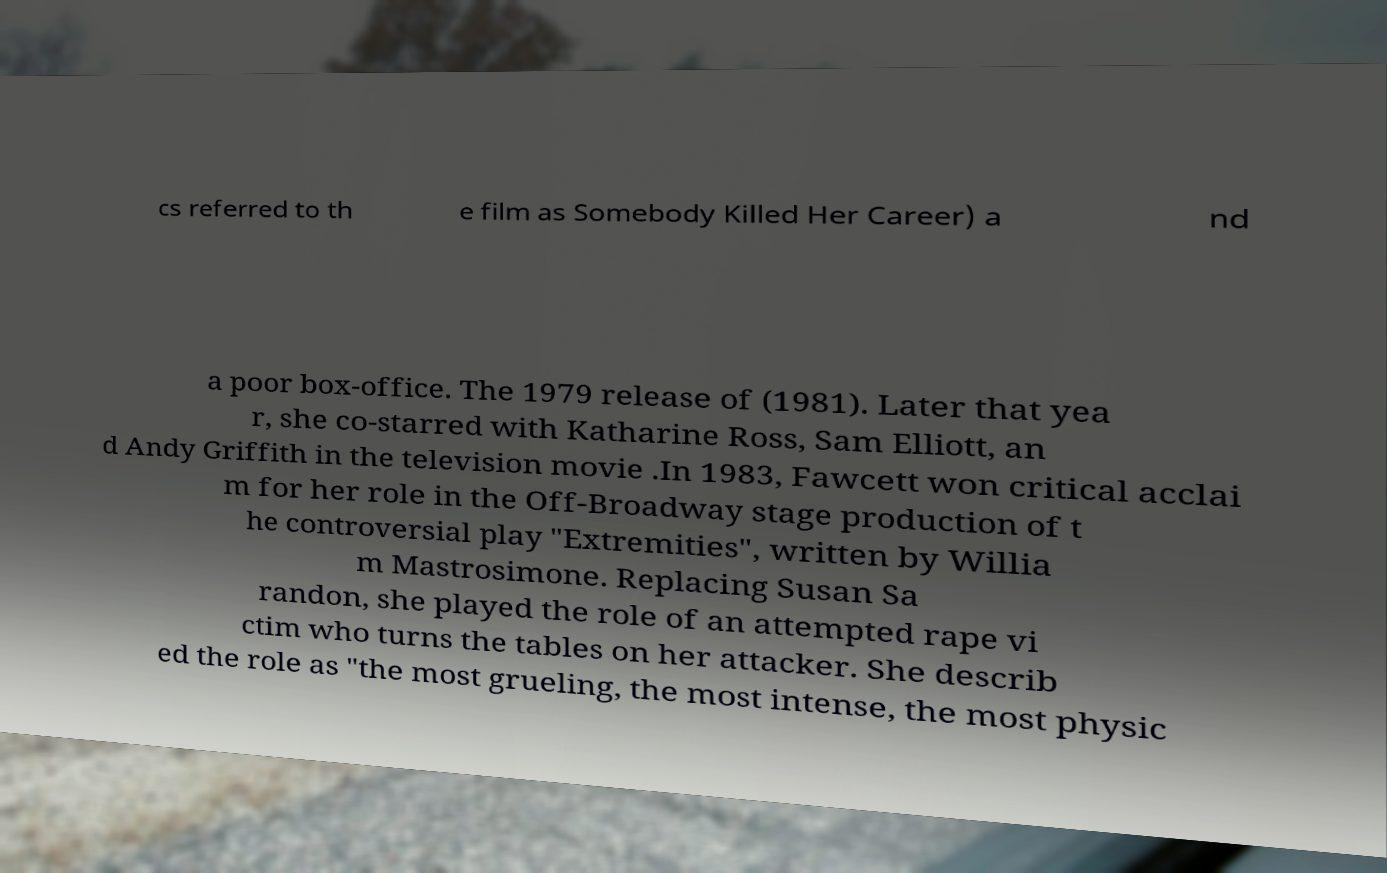What messages or text are displayed in this image? I need them in a readable, typed format. cs referred to th e film as Somebody Killed Her Career) a nd a poor box-office. The 1979 release of (1981). Later that yea r, she co-starred with Katharine Ross, Sam Elliott, an d Andy Griffith in the television movie .In 1983, Fawcett won critical acclai m for her role in the Off-Broadway stage production of t he controversial play "Extremities", written by Willia m Mastrosimone. Replacing Susan Sa randon, she played the role of an attempted rape vi ctim who turns the tables on her attacker. She describ ed the role as "the most grueling, the most intense, the most physic 